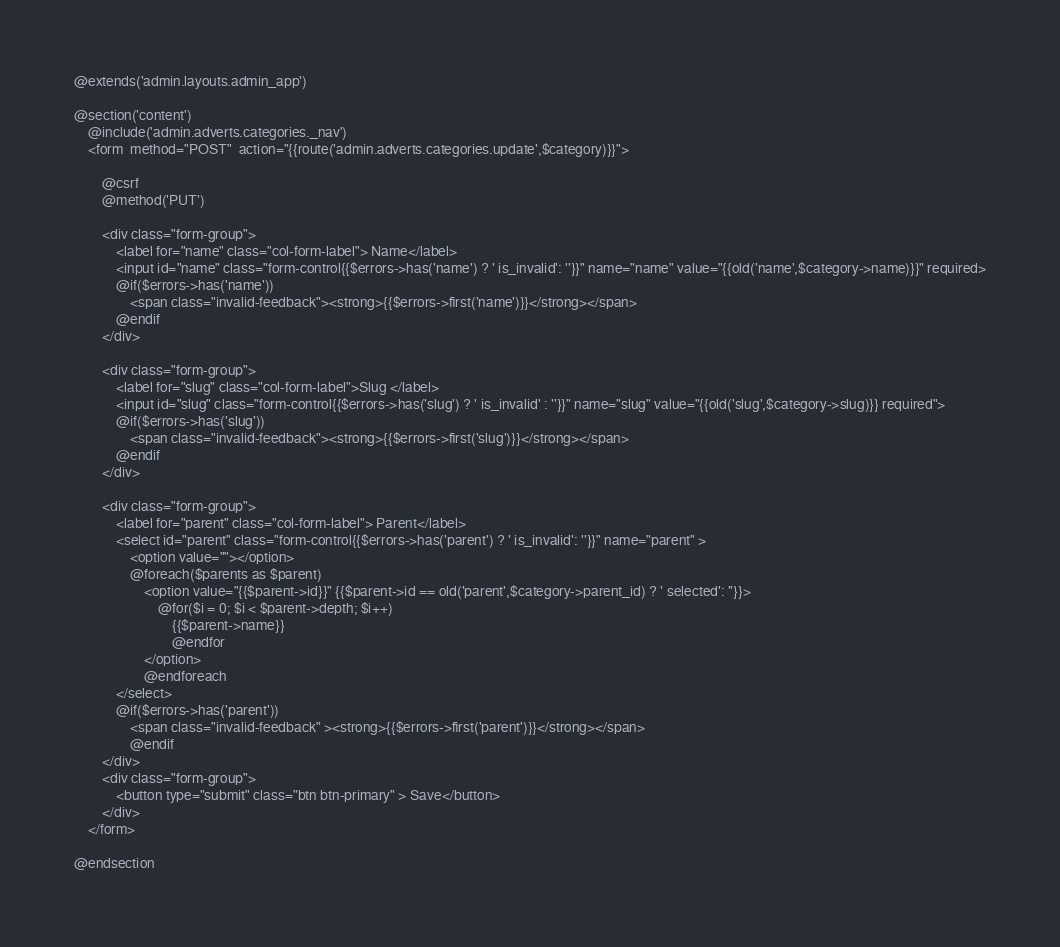Convert code to text. <code><loc_0><loc_0><loc_500><loc_500><_PHP_>@extends('admin.layouts.admin_app')

@section('content')
    @include('admin.adverts.categories._nav')
    <form  method="POST"  action="{{route('admin.adverts.categories.update',$category)}}">

        @csrf
        @method('PUT')

        <div class="form-group">
            <label for="name" class="col-form-label"> Name</label>
            <input id="name" class="form-control{{$errors->has('name') ? ' is_invalid': ''}}" name="name" value="{{old('name',$category->name)}}" required>
            @if($errors->has('name'))
                <span class="invalid-feedback"><strong>{{$errors->first('name')}}</strong></span>
            @endif
        </div>

        <div class="form-group">
            <label for="slug" class="col-form-label">Slug </label>
            <input id="slug" class="form-control{{$errors->has('slug') ? ' is_invalid' : ''}}" name="slug" value="{{old('slug',$category->slug)}} required">
            @if($errors->has('slug'))
                <span class="invalid-feedback"><strong>{{$errors->first('slug')}}</strong></span>
            @endif
        </div>

        <div class="form-group">
            <label for="parent" class="col-form-label"> Parent</label>
            <select id="parent" class="form-control{{$errors->has('parent') ? ' is_invalid': ''}}" name="parent" >
                <option value=""></option>
                @foreach($parents as $parent)
                    <option value="{{$parent->id}}" {{$parent->id == old('parent',$category->parent_id) ? ' selected': ''}}>
                        @for($i = 0; $i < $parent->depth; $i++)
                            {{$parent->name}}
                            @endfor
                    </option>
                    @endforeach
            </select>
            @if($errors->has('parent'))
                <span class="invalid-feedback" ><strong>{{$errors->first('parent')}}</strong></span>
                @endif
        </div>
        <div class="form-group">
            <button type="submit" class="btn btn-primary" > Save</button>
        </div>
    </form>

@endsection</code> 